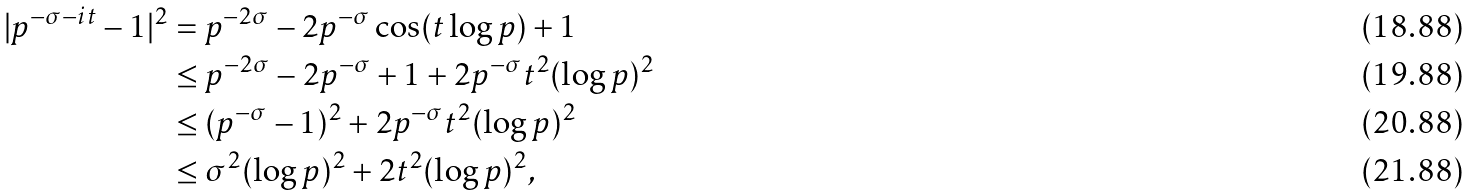Convert formula to latex. <formula><loc_0><loc_0><loc_500><loc_500>| p ^ { - \sigma - i t } - 1 | ^ { 2 } & = p ^ { - 2 \sigma } - 2 p ^ { - \sigma } \cos ( t \log p ) + 1 \\ & \leq p ^ { - 2 \sigma } - 2 p ^ { - \sigma } + 1 + 2 p ^ { - \sigma } t ^ { 2 } ( \log p ) ^ { 2 } \\ & \leq ( p ^ { - \sigma } - 1 ) ^ { 2 } + 2 p ^ { - \sigma } t ^ { 2 } ( \log p ) ^ { 2 } \\ & \leq \sigma ^ { 2 } ( \log p ) ^ { 2 } + 2 t ^ { 2 } ( \log p ) ^ { 2 } ,</formula> 